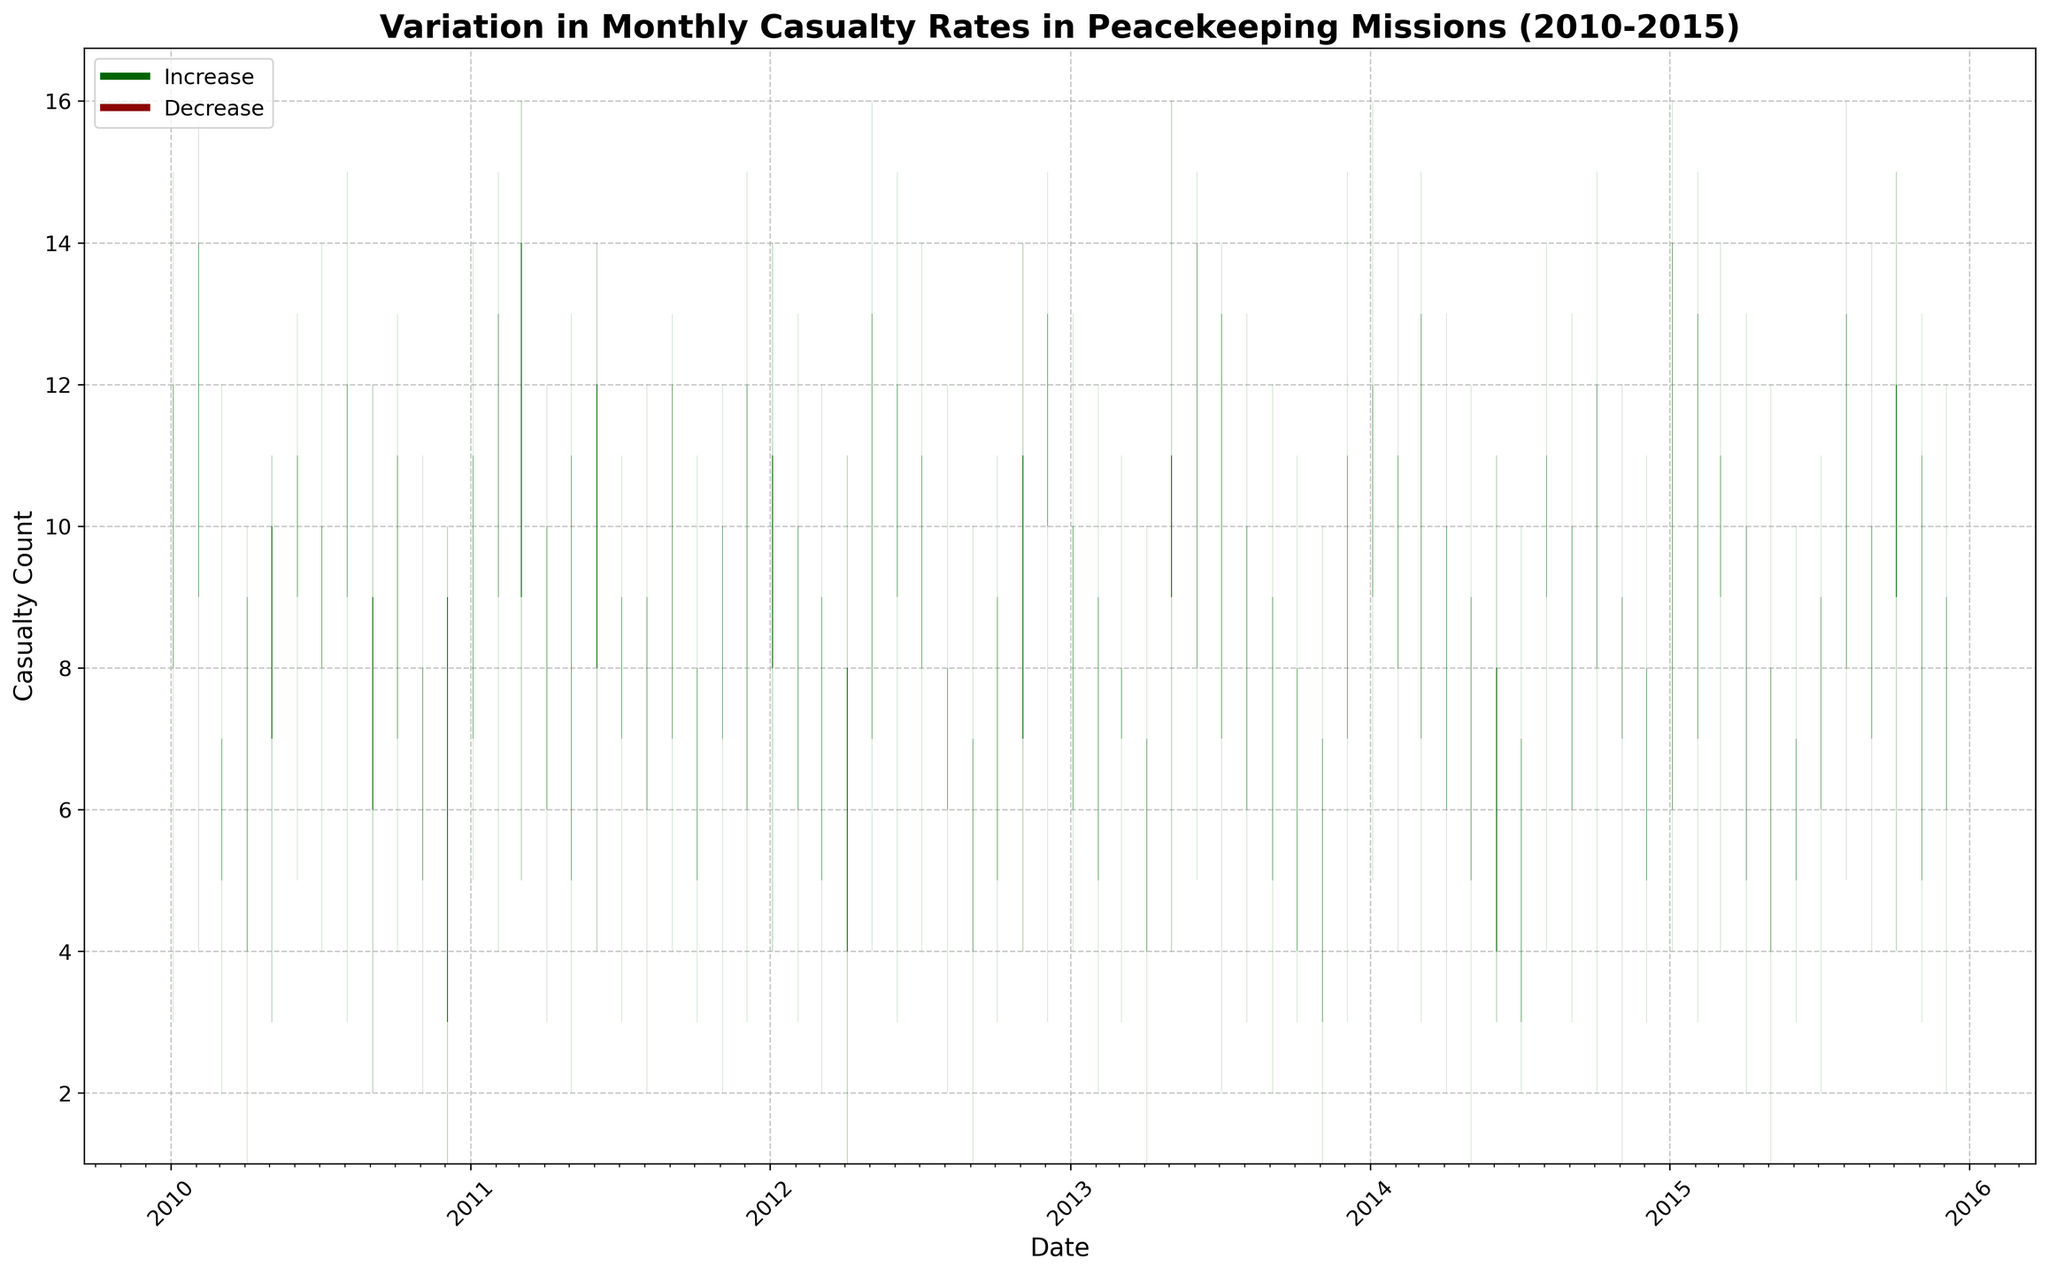What is the title of the graph? The title of the graph is written at the top and provides the overall topic of the plot.
Answer: Variation in Monthly Casualty Rates in Peacekeeping Missions (2010-2015) What do the green bars represent on the graph? Green bars indicate months where the closing casualty count is higher than the opening casualty count, suggesting an increase in casualties.
Answer: Increase How are the dates formatted on the x-axis? The dates on the x-axis are formatted to show the year. Each year's tick label appears at regular intervals.
Answer: Yearly How many major casualty rate increases can you observe in the plot? By counting the number of upward (green) candlestick bars, we can determine the number of major casualty rate increases in the plot.
Answer: 39 Which month and year had the highest casualty rate, and what was the number? By identifying the tallest bar, we find the month and year it represents, along with the numerical value at its peak.
Answer: March 2011, 16 Which year had the highest variation in casualty rates? We need to compare the height of the candlestick bars for each year to determine which one has the widest range from low to high values.
Answer: 2015 What is the general trend of casualty rates between January 2010 and December 2015? Observing the pattern and direction of the candlestick bars over time helps identify whether casualty rates generally increased, decreased, or fluctuated.
Answer: Fluctuated Which country had the most appearances with a decrease in casualties by month? By examining the color and frequency of the drops in casualty rates associated with each country, we can determine this.
Answer: Syria When comparing 2010 and 2015, in which year were the casualty rates more volatile, and how do you know? We assess the frequency and height of candlesticks to determine volatility in each year, focusing on the highs and lows.
Answer: 2015, because it had more frequent and larger bars indicating greater variations What is the difference between the highest and lowest casualties recorded in the period? The highest casualty count (16) is subtracted from the lowest casualty count (1) observed in the candlestick plot.
Answer: 15 